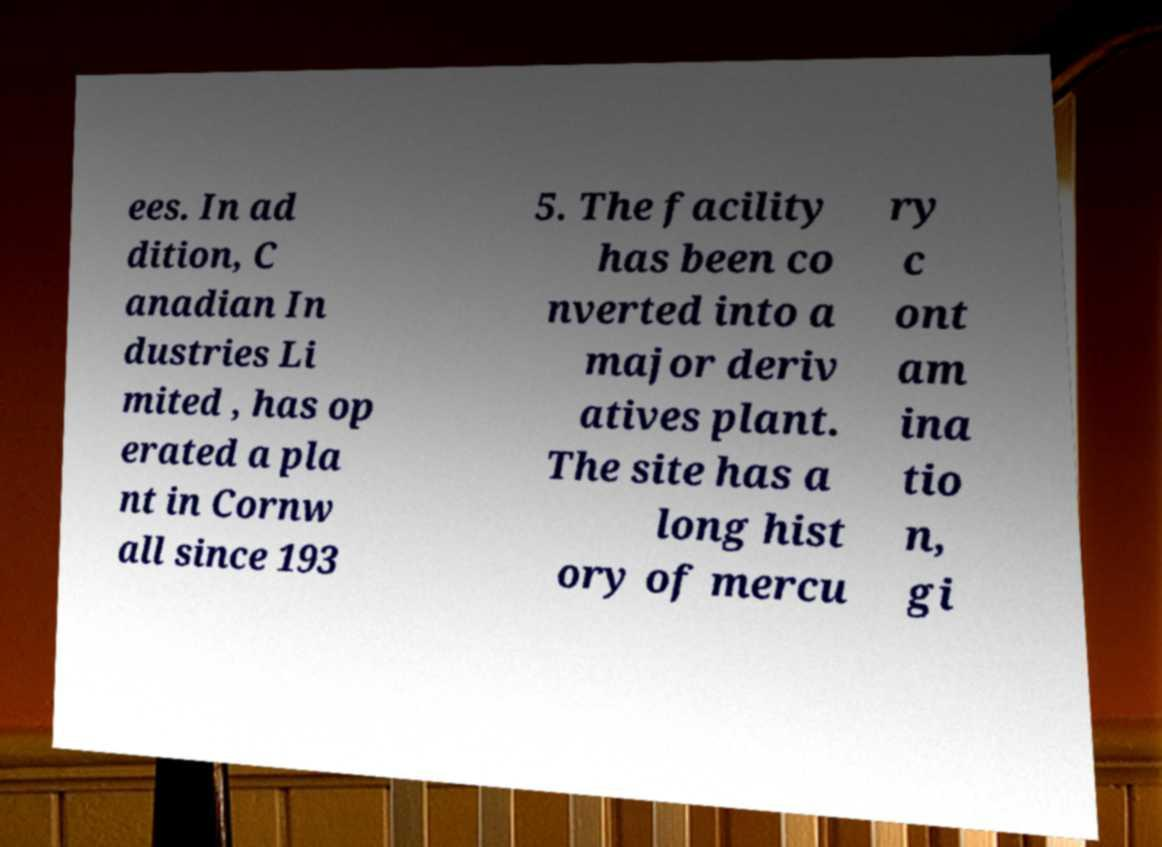Can you accurately transcribe the text from the provided image for me? ees. In ad dition, C anadian In dustries Li mited , has op erated a pla nt in Cornw all since 193 5. The facility has been co nverted into a major deriv atives plant. The site has a long hist ory of mercu ry c ont am ina tio n, gi 